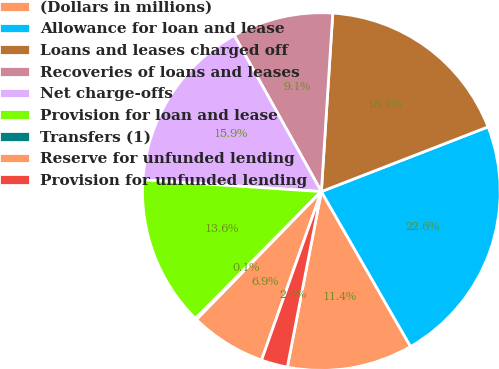Convert chart. <chart><loc_0><loc_0><loc_500><loc_500><pie_chart><fcel>(Dollars in millions)<fcel>Allowance for loan and lease<fcel>Loans and leases charged off<fcel>Recoveries of loans and leases<fcel>Net charge-offs<fcel>Provision for loan and lease<fcel>Transfers (1)<fcel>Reserve for unfunded lending<fcel>Provision for unfunded lending<nl><fcel>11.36%<fcel>22.58%<fcel>18.09%<fcel>9.12%<fcel>15.85%<fcel>13.61%<fcel>0.14%<fcel>6.87%<fcel>2.38%<nl></chart> 